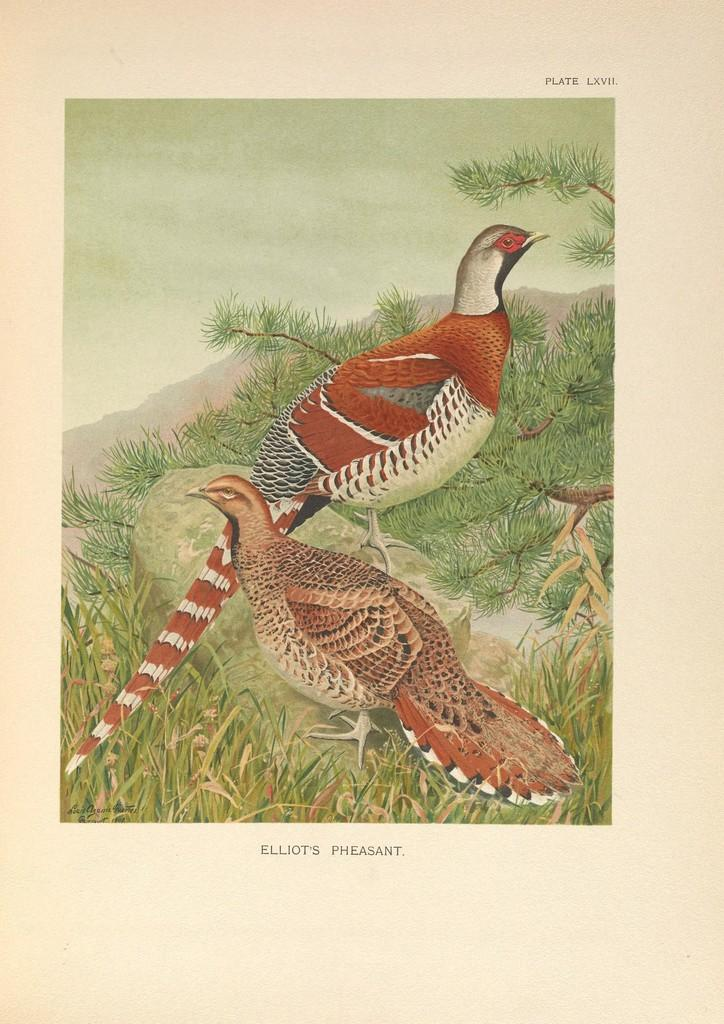What is depicted on the poster in the image? The poster contains two birds, trees, and hills. What type of landscape is shown on the poster? The poster depicts a landscape with trees and hills. Are there any visible watermarks on the poster? Yes, there are watermarks visible in the image. What type of prison can be seen in the image? There is no prison present in the image; it features a poster with birds, trees, and hills. How is the squirrel using the poster in the image? There is no squirrel present in the image, so it cannot be using the poster. 